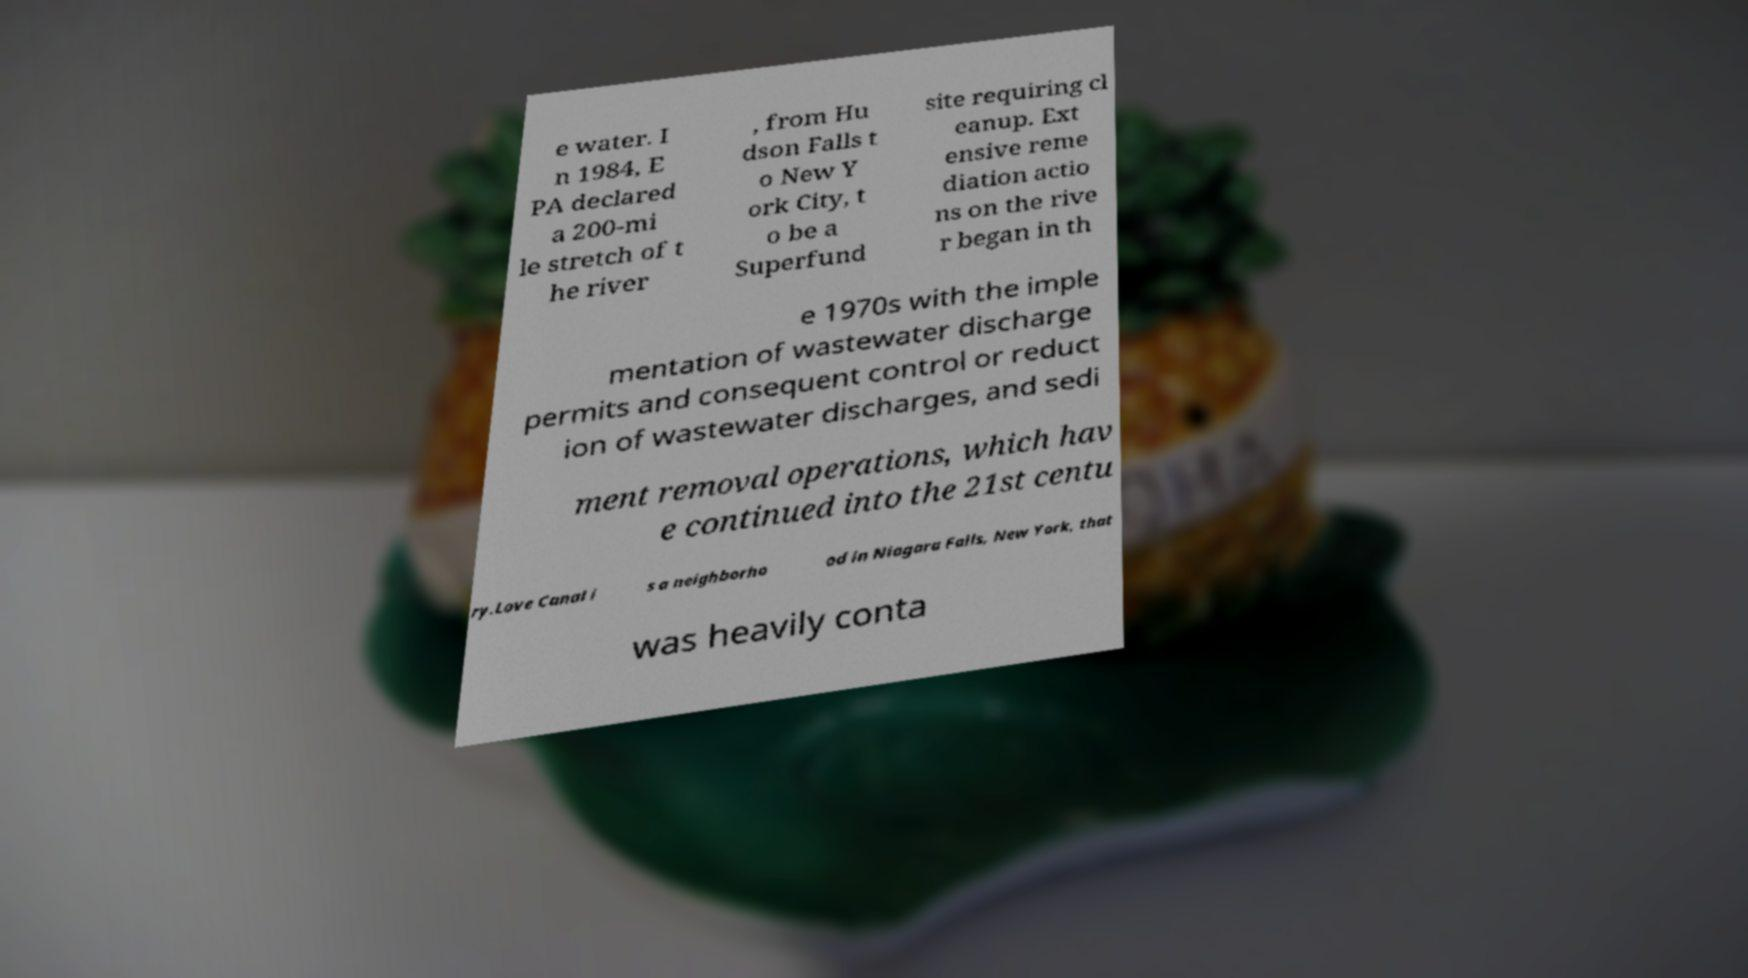Could you extract and type out the text from this image? e water. I n 1984, E PA declared a 200-mi le stretch of t he river , from Hu dson Falls t o New Y ork City, t o be a Superfund site requiring cl eanup. Ext ensive reme diation actio ns on the rive r began in th e 1970s with the imple mentation of wastewater discharge permits and consequent control or reduct ion of wastewater discharges, and sedi ment removal operations, which hav e continued into the 21st centu ry.Love Canal i s a neighborho od in Niagara Falls, New York, that was heavily conta 